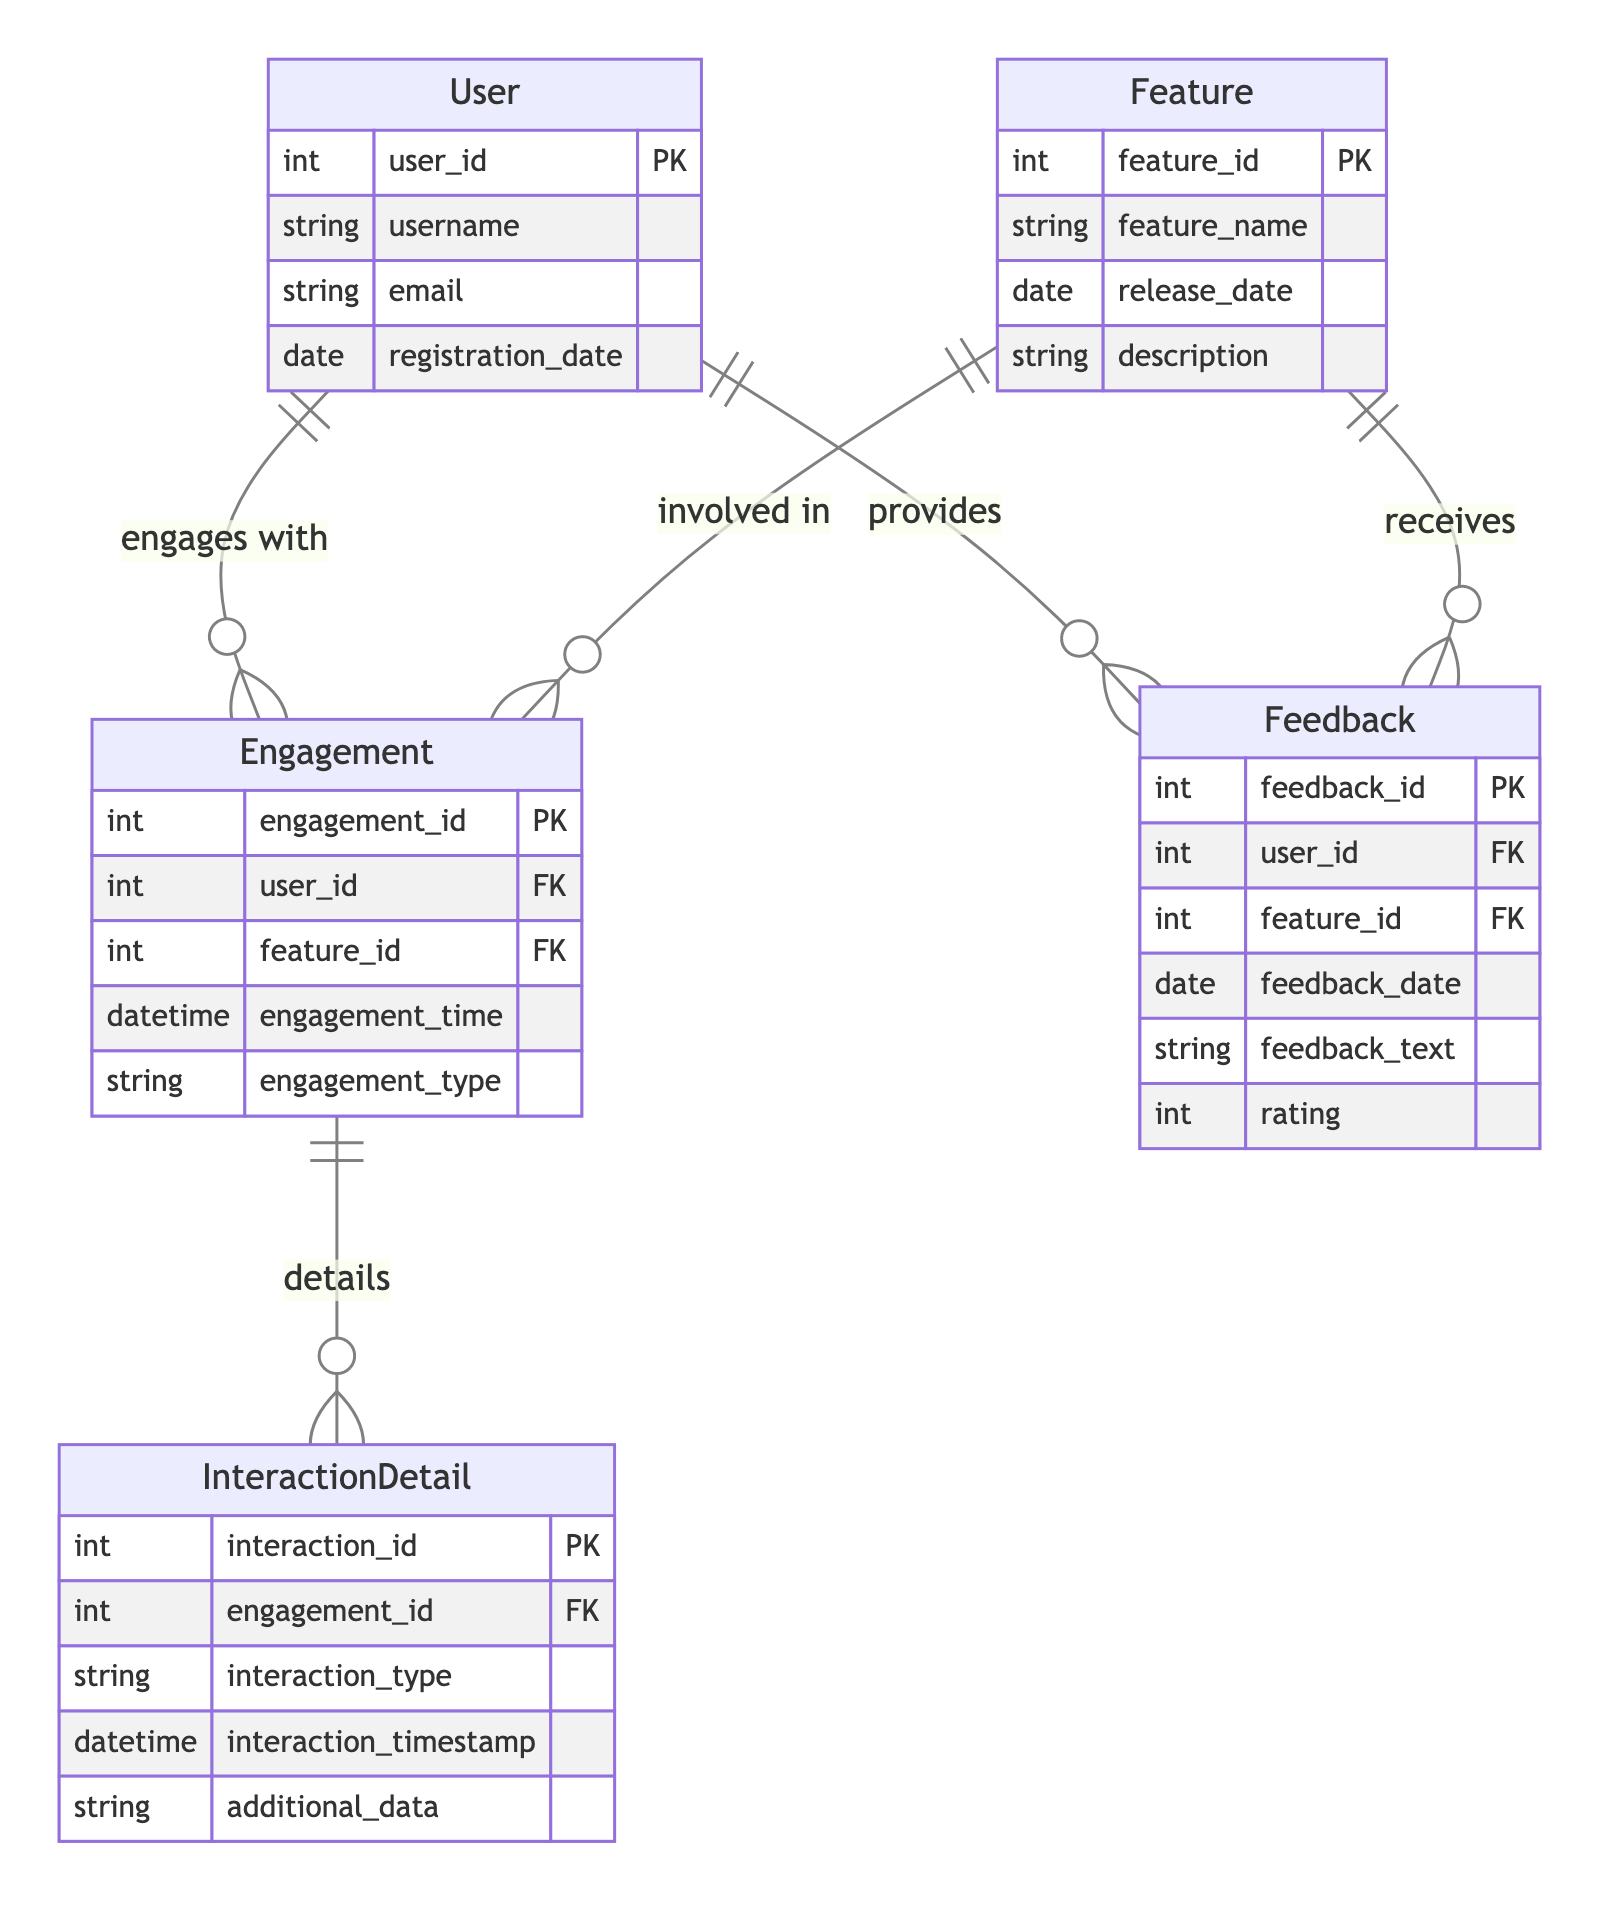What is the primary key of the User entity? The primary key is the unique identifier for the User entity, which is specified as user_id in the diagram.
Answer: user_id How many attributes does the Feature entity have? The Feature entity includes four attributes: feature_id, feature_name, release_date, and description, as listed in the diagram.
Answer: 4 What relationship exists between User and Engagement? The relationship between User and Engagement indicates that a User engages with an Engagement, represented as "engages with" in the diagram.
Answer: engages with How many foreign keys are in the Engagement entity? The Engagement entity has two foreign keys, which are user_id (referring to User) and feature_id (referring to Feature).
Answer: 2 What is the primary key of the Feedback entity? The Feedback entity's primary key, which identifies each feedback uniquely, is feedback_id, as indicated in the diagram.
Answer: feedback_id Which entity provides feedback? The Feedback entity includes a foreign key user_id, indicating that the User provides feedback, as shown by the relationship in the diagram.
Answer: User What type of relationship exists between Feature and Feedback? The relationship between Feature and Feedback is that the Feature receives feedback, which is described by the term "receives" in the diagram.
Answer: receives How many details can an Engagement have? Each Engagement can have multiple InteractionDetails as indicated by the relationship between Engagement and InteractionDetail, which is represented as "details".
Answer: multiple Which attribute in InteractionDetail links back to Engagement? The attribute in InteractionDetail that links back to Engagement is engagement_id, which serves as a foreign key referencing Engagement.
Answer: engagement_id 